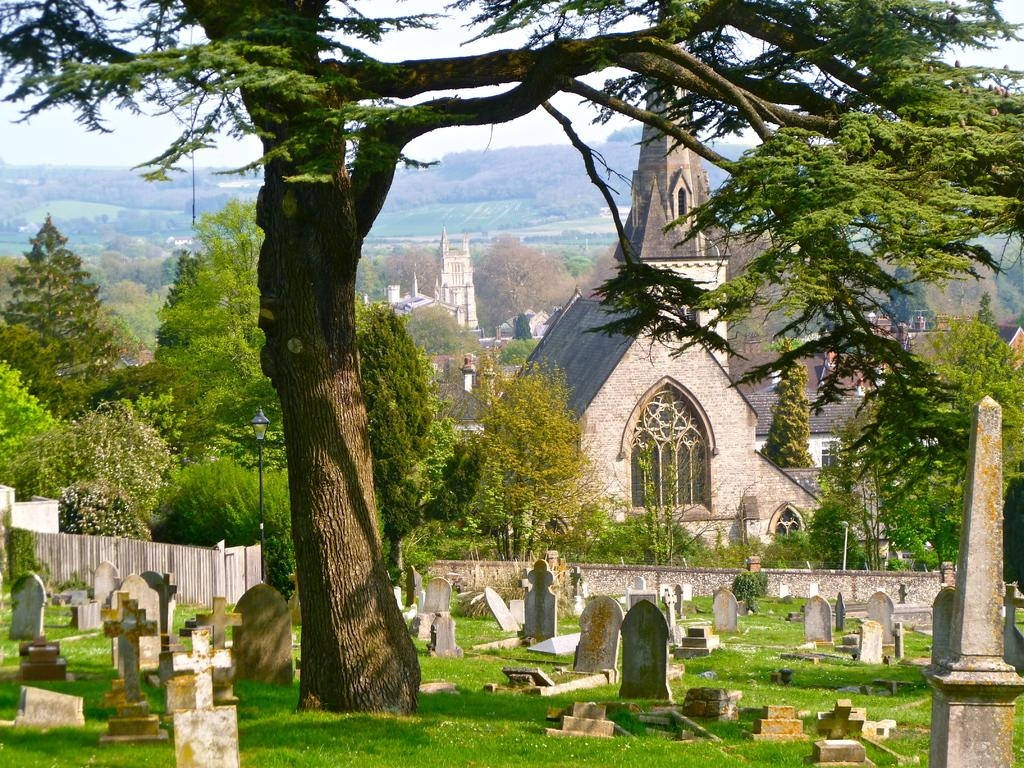What type of location is depicted in the image? The image contains a graveyard. What can be seen in the foreground of the image? There is a tree in the foreground of the image. What is visible in the background of the image? There is a group of buildings and trees visible in the background of the image. What part of the natural environment is visible in the image? The sky is visible in the background of the image. What type of treatment is being administered to the lake in the image? There is no lake present in the image, so no treatment can be administered to it. 